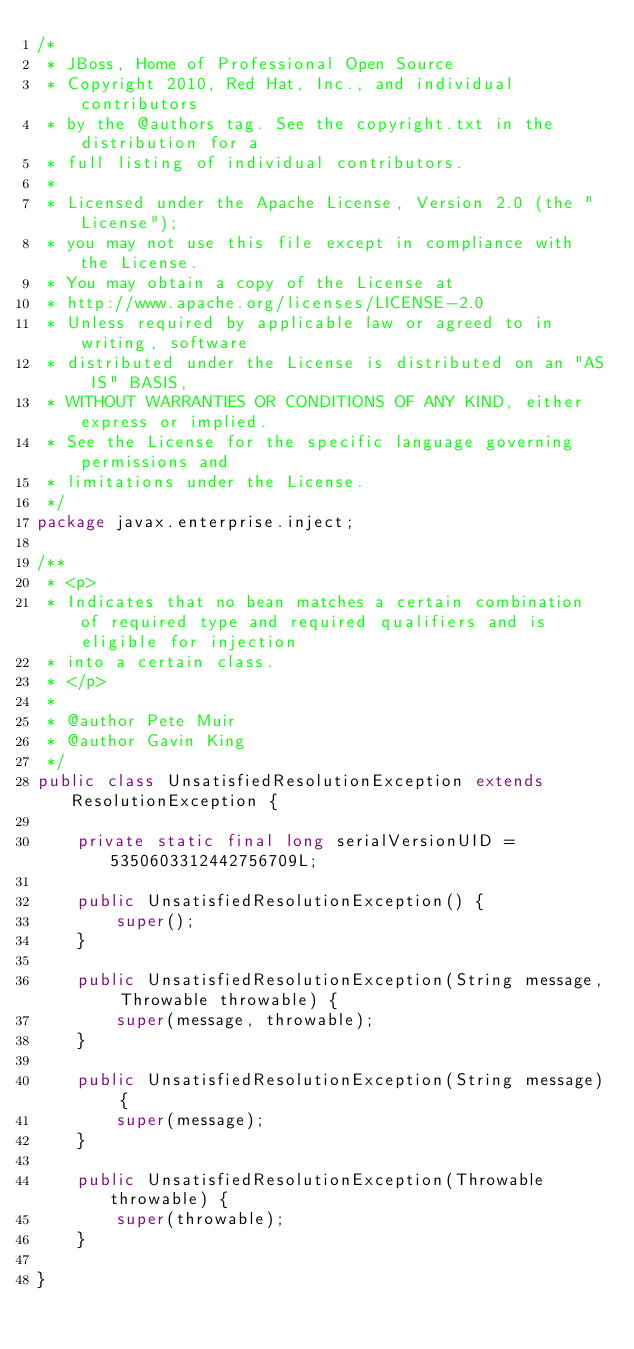<code> <loc_0><loc_0><loc_500><loc_500><_Java_>/*
 * JBoss, Home of Professional Open Source
 * Copyright 2010, Red Hat, Inc., and individual contributors
 * by the @authors tag. See the copyright.txt in the distribution for a
 * full listing of individual contributors.
 *
 * Licensed under the Apache License, Version 2.0 (the "License");
 * you may not use this file except in compliance with the License.
 * You may obtain a copy of the License at
 * http://www.apache.org/licenses/LICENSE-2.0
 * Unless required by applicable law or agreed to in writing, software
 * distributed under the License is distributed on an "AS IS" BASIS,  
 * WITHOUT WARRANTIES OR CONDITIONS OF ANY KIND, either express or implied.
 * See the License for the specific language governing permissions and
 * limitations under the License.
 */
package javax.enterprise.inject;

/**
 * <p>
 * Indicates that no bean matches a certain combination of required type and required qualifiers and is eligible for injection
 * into a certain class.
 * </p>
 * 
 * @author Pete Muir
 * @author Gavin King
 */
public class UnsatisfiedResolutionException extends ResolutionException {

    private static final long serialVersionUID = 5350603312442756709L;

    public UnsatisfiedResolutionException() {
        super();
    }

    public UnsatisfiedResolutionException(String message, Throwable throwable) {
        super(message, throwable);
    }

    public UnsatisfiedResolutionException(String message) {
        super(message);
    }

    public UnsatisfiedResolutionException(Throwable throwable) {
        super(throwable);
    }

}
</code> 